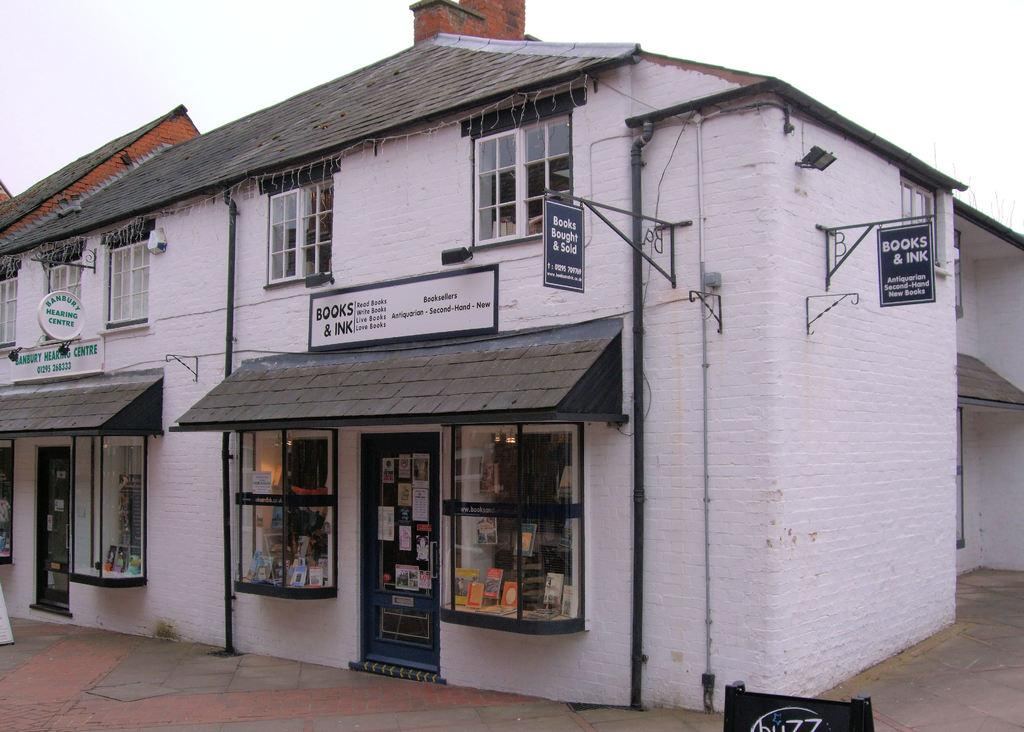What type of structures can be seen in the image? There are buildings in the image. What type of establishments are present in the image? There are stores in the image. What helps identify the stores in the image? Name boards are present in the image. What else can be seen in the image besides buildings and stores? Pipelines are visible in the image. What is visible in the background of the image? The sky is visible in the background of the image. What type of slip can be seen on the floor of the stores in the image? There is no slip visible on the floor of the stores in the image. What suggestion can be made to improve the lighting in the image? The provided information does not allow for a suggestion to improve the lighting in the image, as it only describes what is present. 